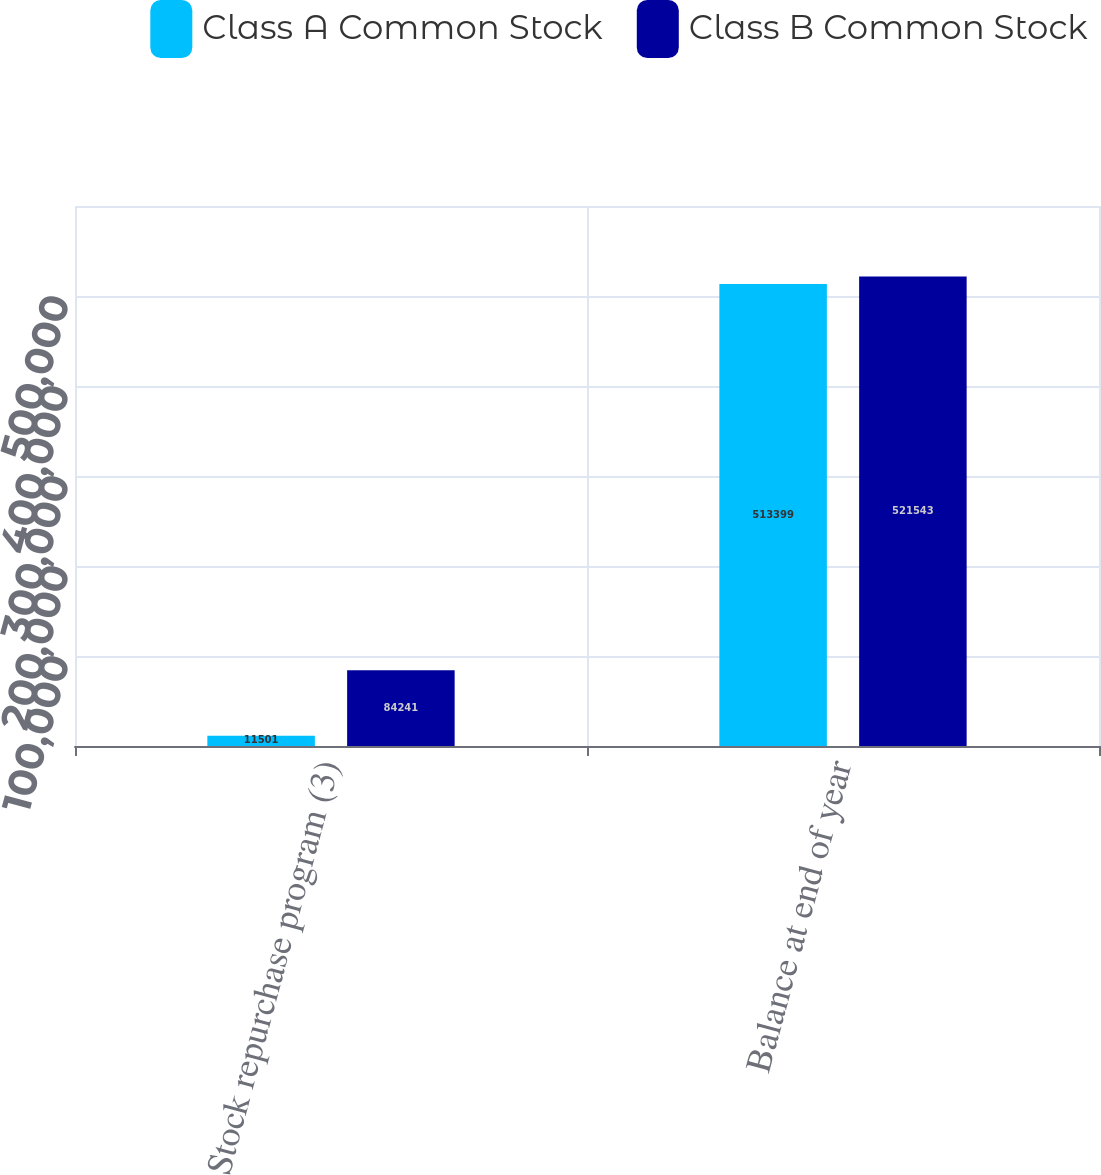<chart> <loc_0><loc_0><loc_500><loc_500><stacked_bar_chart><ecel><fcel>Stock repurchase program (3)<fcel>Balance at end of year<nl><fcel>Class A Common Stock<fcel>11501<fcel>513399<nl><fcel>Class B Common Stock<fcel>84241<fcel>521543<nl></chart> 